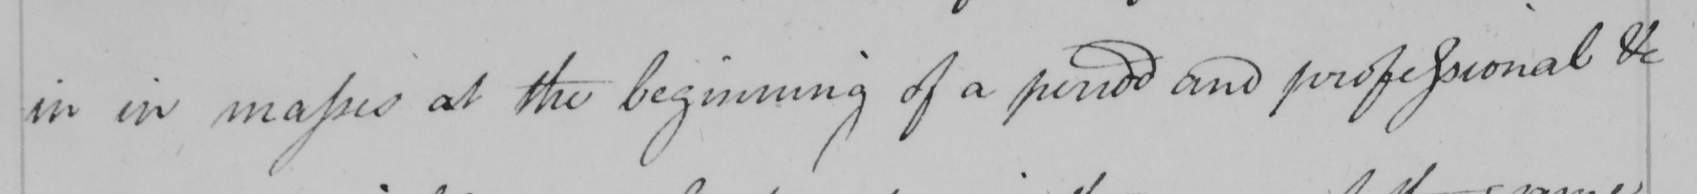What does this handwritten line say? in in masses at the beginning of a period and professional &c 